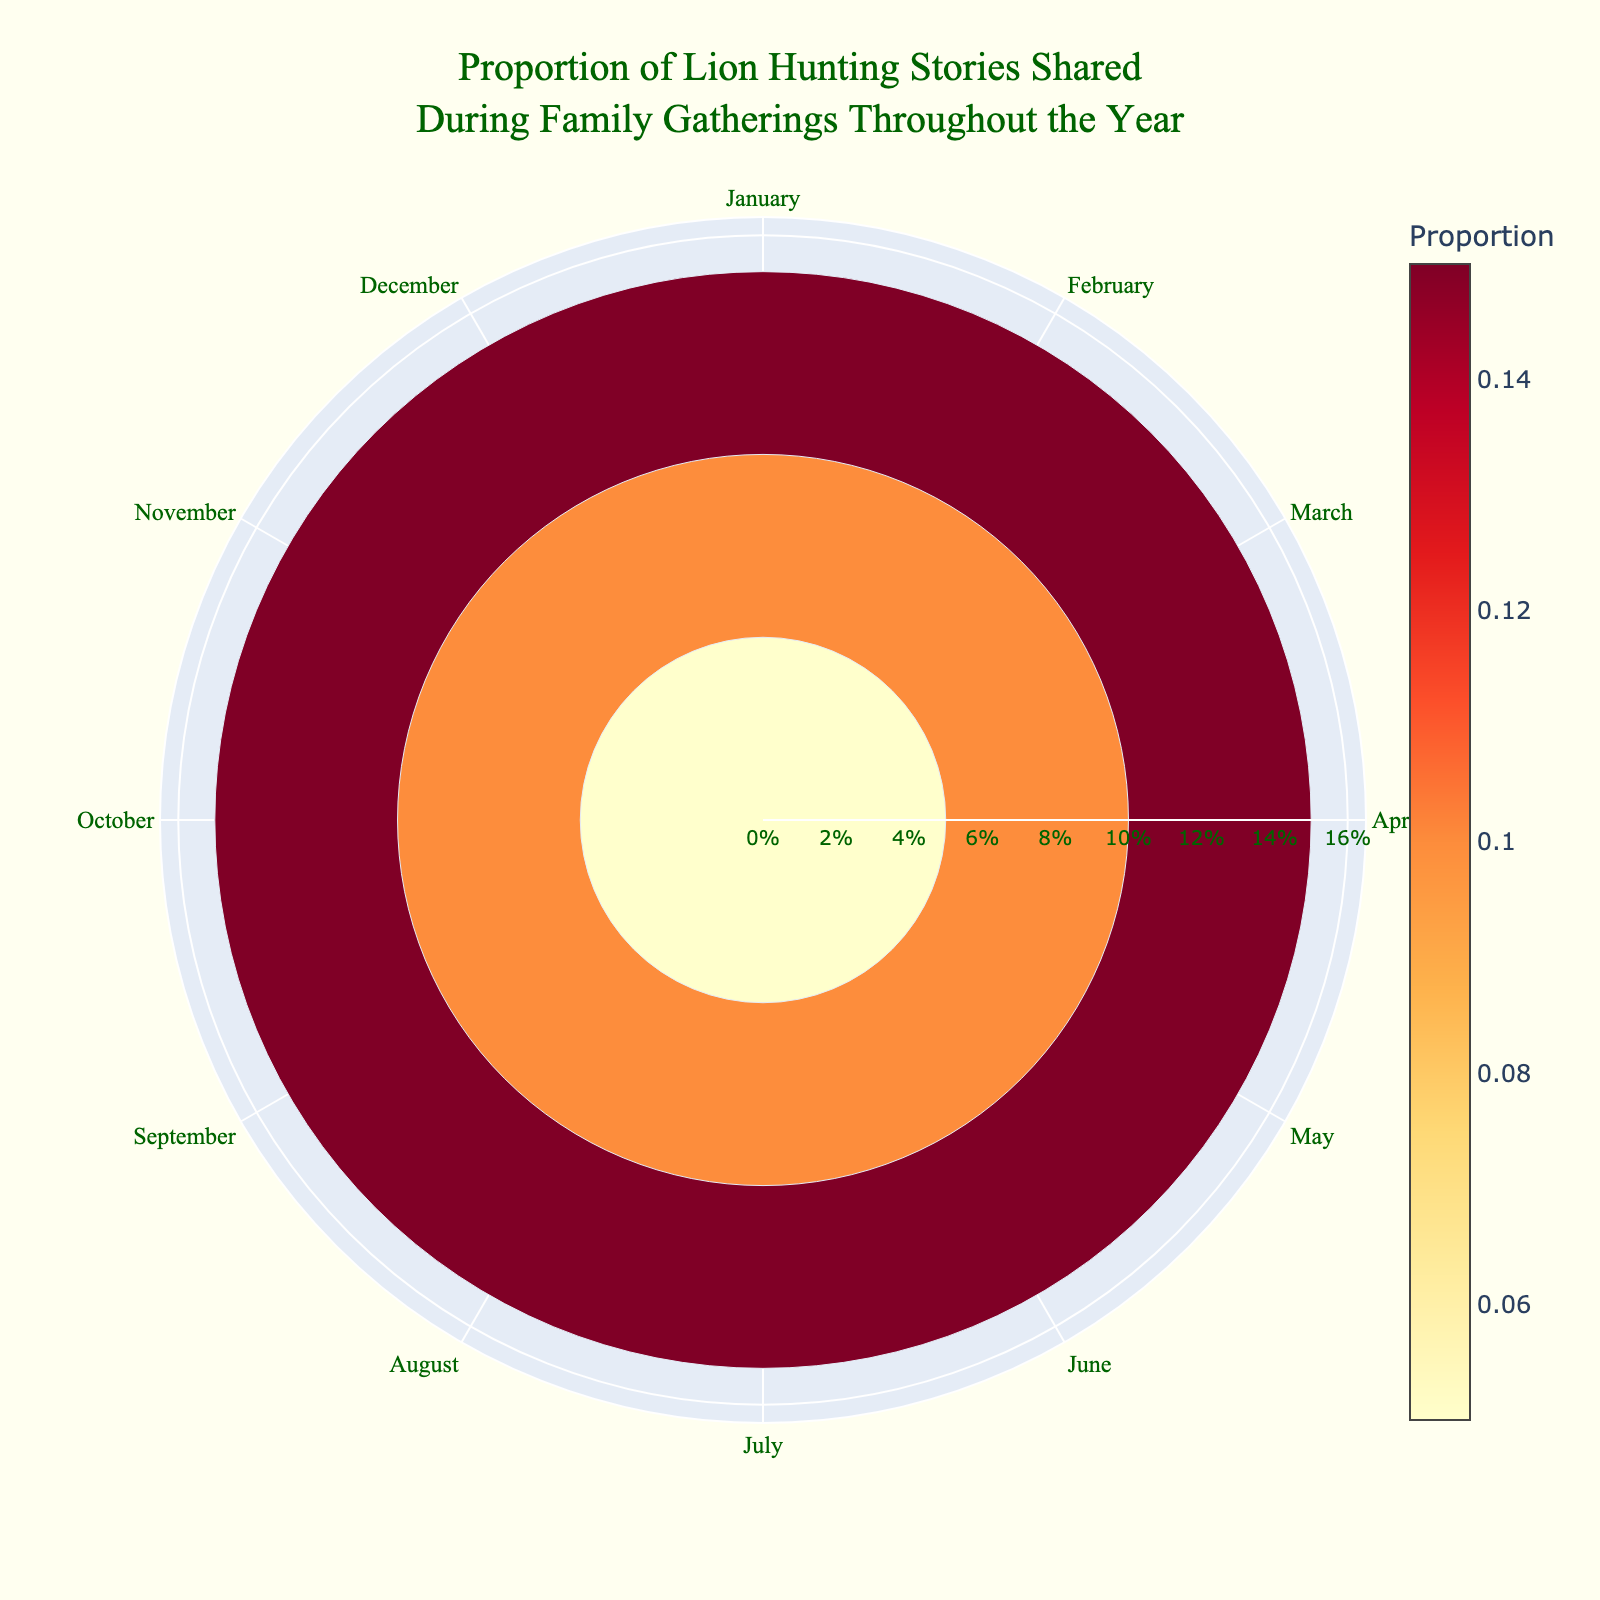What is the title of the figure? The title of the figure appears at the top and usually provides a summary of what the chart represents. Look for a large font text at the top center of the image.
Answer: Proportion of Lion Hunting Stories Shared During Family Gatherings Throughout the Year Which months have the highest proportion of hunting stories? To find the months with the highest proportions, look for the segments that extend farthest from the center of the polar area chart.
Answer: April and October What is the proportion of hunting stories shared in March? To find this value, locate March on the chart and check how far its segment extends from the center. The proportion is often displayed in or near the segment.
Answer: 0.10 How many months have a proportion of 0.10? Count the segments that extend to the 0.10 mark. This can be seen around the circle where segments reach equivalent distances.
Answer: Three months (March, May, and September) How does the proportion of hunting stories shared in June compare to December? Check the lengths of the segments for June and December, and compare their distances from the center.
Answer: They are equal What's the average proportion of hunting stories from January to March? Add the proportions of January, February, and March, then divide by the number of months (3). (0.05 + 0.05 + 0.10) / 3
Answer: 0.067 Which month has the smallest segment in terms of proportion? Identify the segment that is shortest, indicating the smallest proportion.
Answer: January, February, June, July, December What's the difference in proportion between April and August? Subtract the proportion of August from that of April. (0.15 - 0.05)
Answer: 0.10 Are there any months with the same proportion of hunting stories shared? Look for segments that extend to the same distance from the center to determine if they represent the same proportion.
Answer: Yes, January and February; May and September; June, July, and December have the same proportions within their respective pairs When comparing May and November, which month shared more hunting stories and by how much? Compare the lengths of the segments of May and November and calculate the difference by subtraction. (0.10 - 0.10)
Answer: Both have the same proportion 